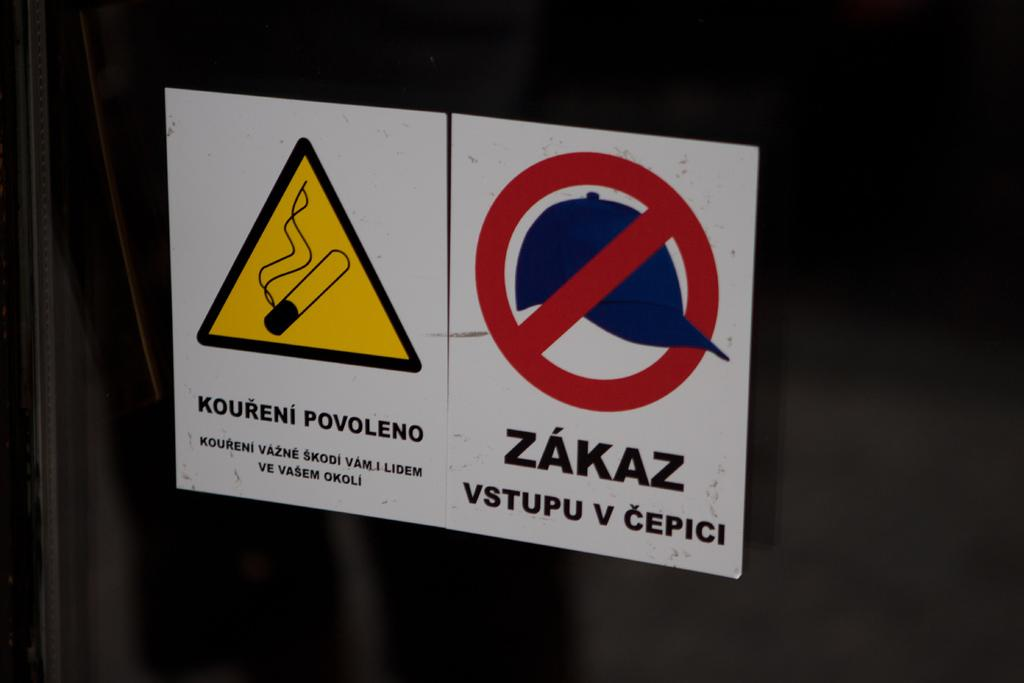<image>
Render a clear and concise summary of the photo. A white sign that says Koureni Povoleno is next to another sign that says Zakaz Vstupu v Cepici. 